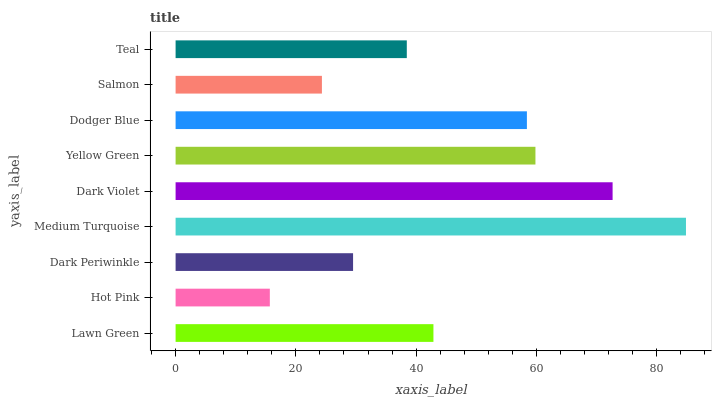Is Hot Pink the minimum?
Answer yes or no. Yes. Is Medium Turquoise the maximum?
Answer yes or no. Yes. Is Dark Periwinkle the minimum?
Answer yes or no. No. Is Dark Periwinkle the maximum?
Answer yes or no. No. Is Dark Periwinkle greater than Hot Pink?
Answer yes or no. Yes. Is Hot Pink less than Dark Periwinkle?
Answer yes or no. Yes. Is Hot Pink greater than Dark Periwinkle?
Answer yes or no. No. Is Dark Periwinkle less than Hot Pink?
Answer yes or no. No. Is Lawn Green the high median?
Answer yes or no. Yes. Is Lawn Green the low median?
Answer yes or no. Yes. Is Salmon the high median?
Answer yes or no. No. Is Dark Violet the low median?
Answer yes or no. No. 